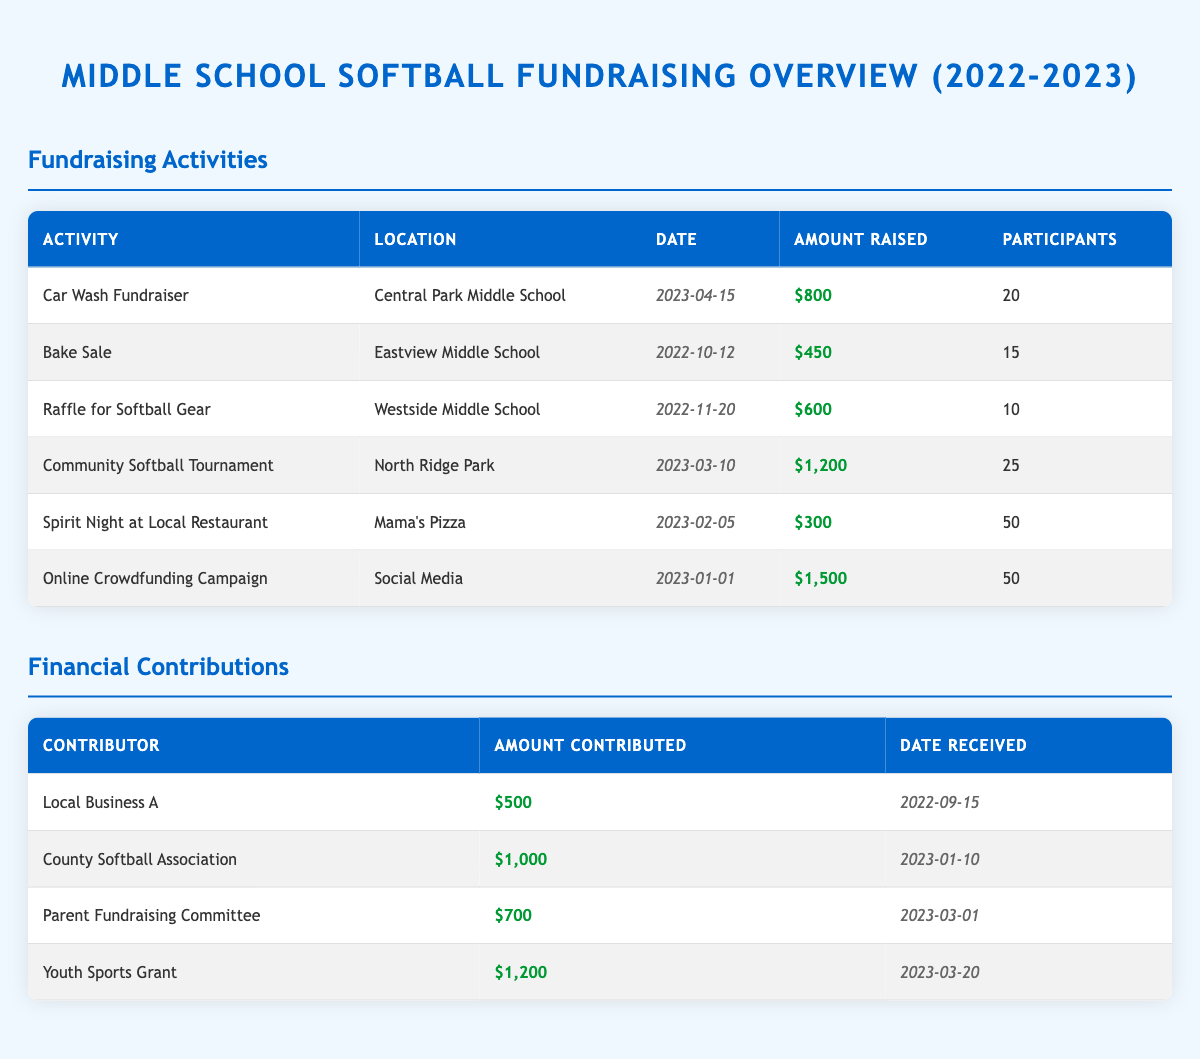What was the largest amount raised in a single fundraising activity? The fundraising activities are listed in the table, and upon examining the "Amount Raised" column, the highest value is $1,500 from the "Online Crowdfunding Campaign."
Answer: $1,500 How many total participants were involved in the fundraising activities? To find the total participants, we sum the "Participants" column values: 20 (Car Wash) + 15 (Bake Sale) + 10 (Raffle) + 25 (Tournament) + 50 (Spirit Night) + 50 (Crowdfunding) = 170.
Answer: 170 Did the "Community Softball Tournament" raise more than $1,000? Looking at the "Amount Raised" for the "Community Softball Tournament," which is $1,200, we see that it is indeed greater than $1,000.
Answer: Yes How many fundraising activities raised less than $500? We examine each activity's raised amount. The "Bake Sale" raised $450 and the "Spirit Night" raised $300. There are two activities below $500.
Answer: 2 What is the total amount raised from all fundraising activities? We add up all the amounts from the "Amount Raised" column: $800 (Car Wash) + $450 (Bake Sale) + $600 (Raffle) + $1,200 (Tournament) + $300 (Spirit Night) + $1,500 (Crowdfunding) = $3,850.
Answer: $3,850 Which contributor gave the highest amount and how much was it? In the "Financial Contributions" table, we compare amounts contributed. The "Youth Sports Grant" contributed $1,200, which is the highest amount listed.
Answer: Youth Sports Grant, $1,200 How many contributors donated an amount greater than $700? We check the "Amount Contributed" and see which entries exceed $700: "County Softball Association" ($1,000), "Parent Fundraising Committee" ($700), and "Youth Sports Grant" ($1,200). Therefore, there are three contributors above $700.
Answer: 3 Was there a fundraising activity with more than 25 participants? By reviewing the "Participants" column, the maximum participation was 50 in both the "Spirit Night" and "Online Crowdfunding Campaign", which are both more than 25.
Answer: Yes What was the average amount raised per fundraising activity? To obtain the average, we sum the amount raised: $800 + $450 + $600 + $1,200 + $300 + $1,500 = $3,850. There were 6 activities, so we divide $3,850 by 6 which gives approximately $641.67.
Answer: $641.67 